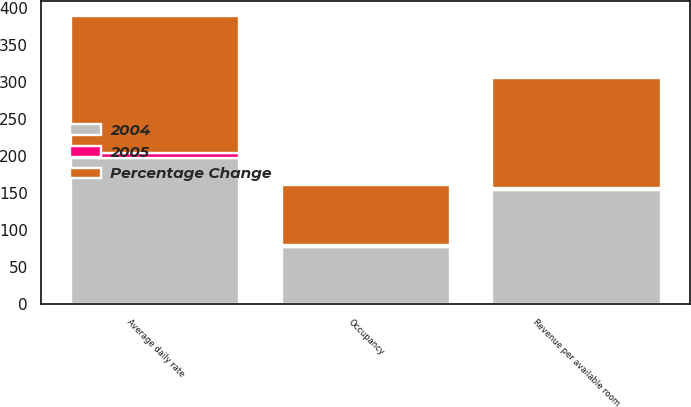<chart> <loc_0><loc_0><loc_500><loc_500><stacked_bar_chart><ecel><fcel>Occupancy<fcel>Average daily rate<fcel>Revenue per available room<nl><fcel>2004<fcel>77.4<fcel>197.82<fcel>153.95<nl><fcel>Percentage Change<fcel>80<fcel>185.42<fcel>149.04<nl><fcel>2005<fcel>3.2<fcel>6.7<fcel>3.3<nl></chart> 